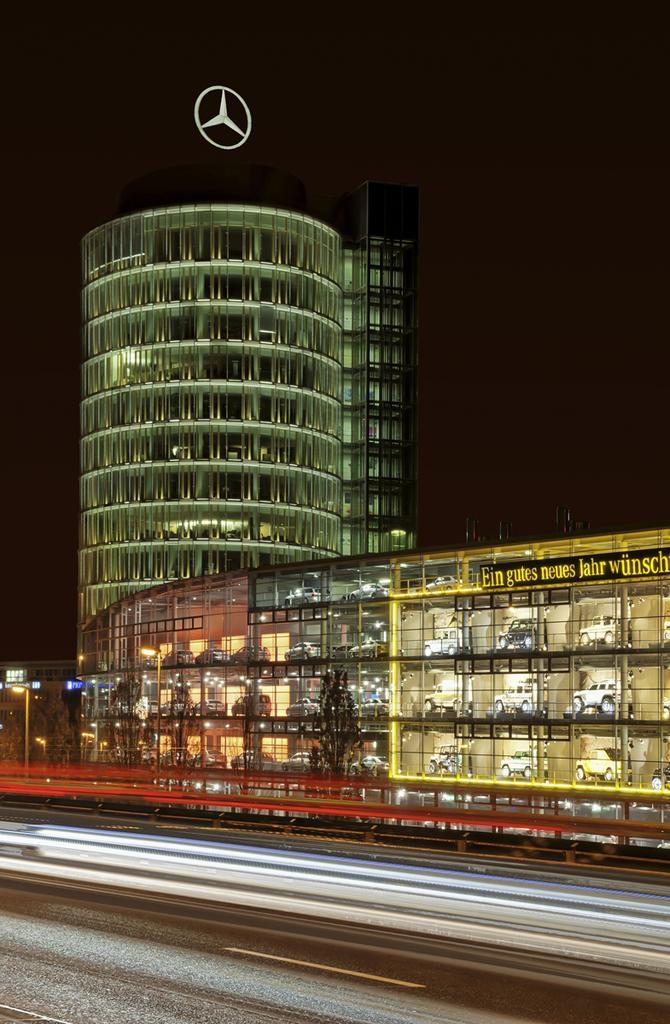In one or two sentences, can you explain what this image depicts? This is an image clicked in the dark. At the bottom of the image I can see a road. In the background there is a building. 